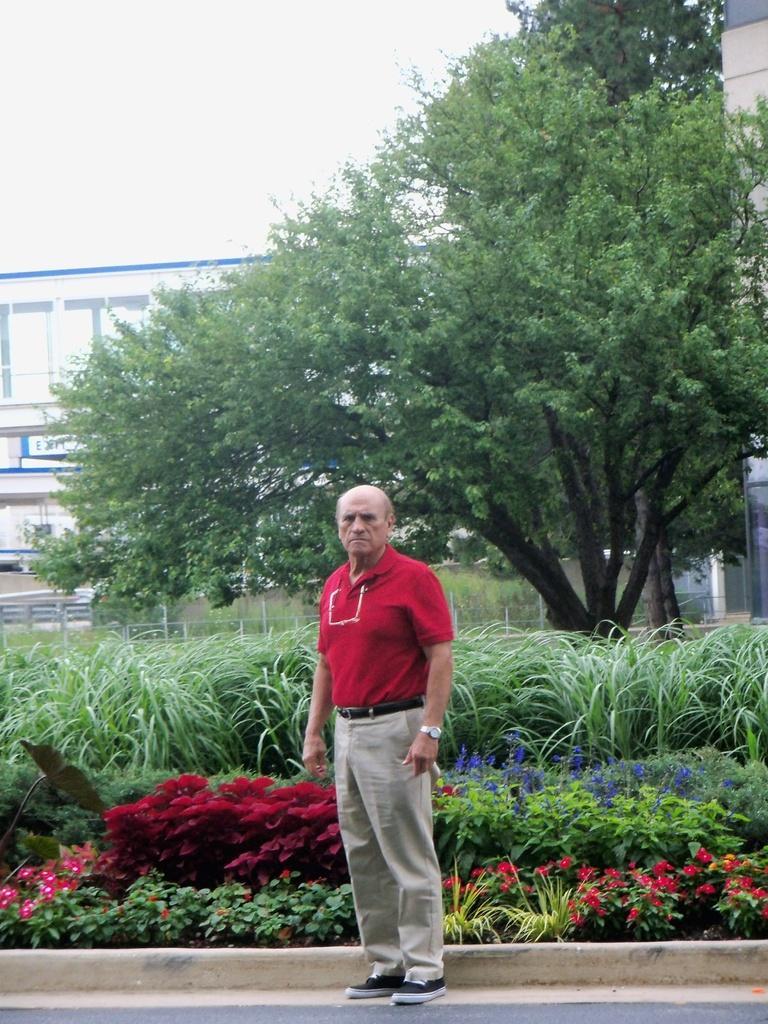Could you give a brief overview of what you see in this image? In this picture we can see a man standing on the ground. At the back of him we can see flowers, plants, fence, trees, buildings and the sky. 